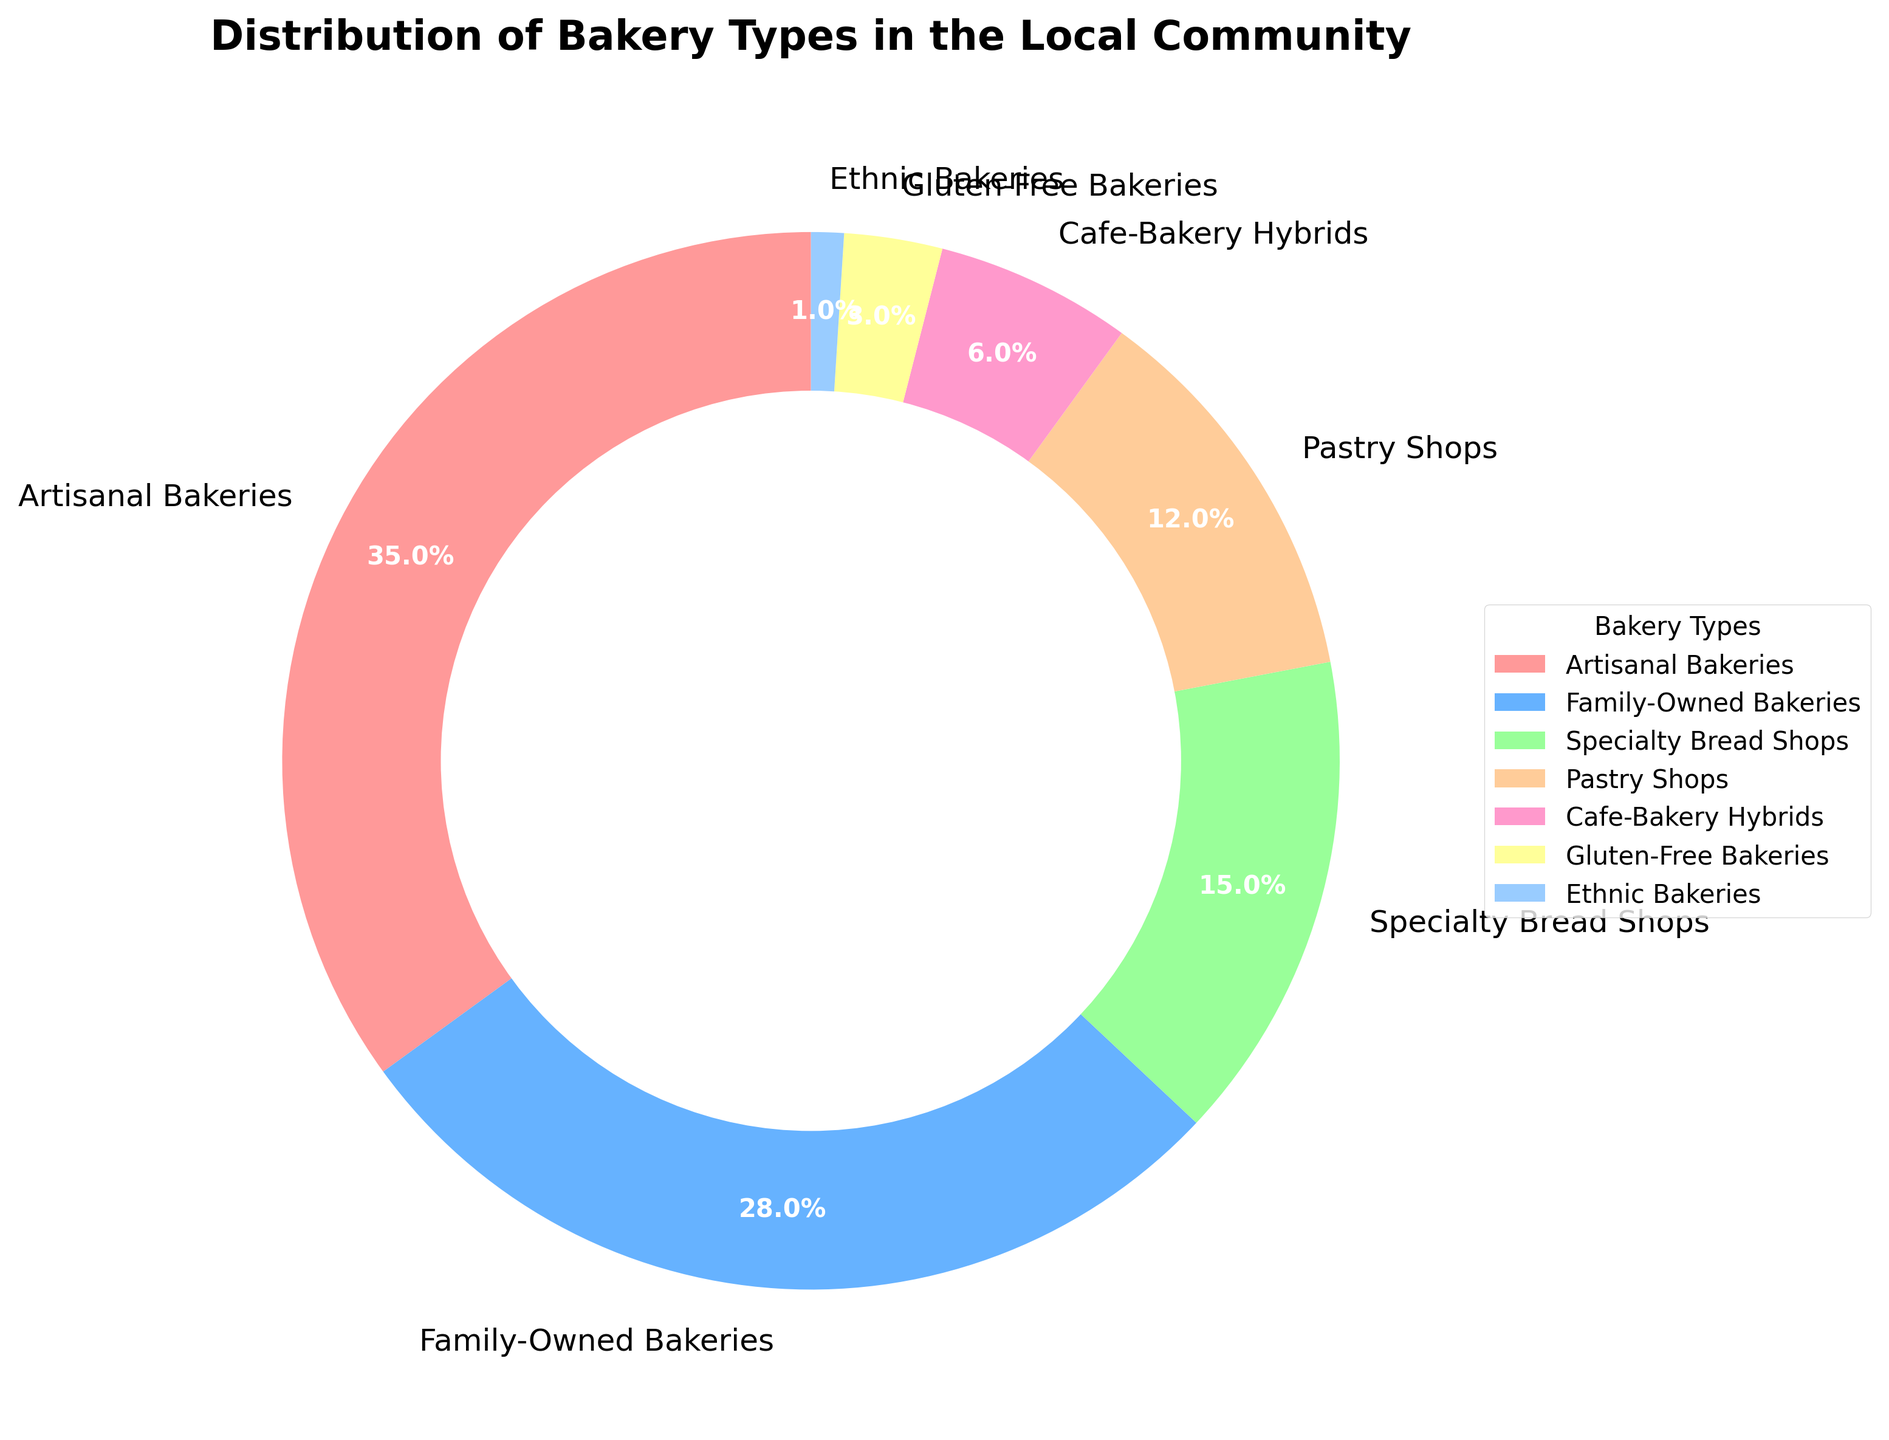How many more percentage points do Artisanal Bakeries have compared to Gluten-Free Bakeries? Artisanal Bakeries have 35%, and Gluten-Free Bakeries have 3%. To find the difference, subtract 3 from 35.
Answer: 32 Which type of bakery has the second-highest percentage? The segment with the second-highest percentage is Family-Owned Bakeries at 28%, just after Artisanal Bakeries at 35%.
Answer: Family-Owned Bakeries What is the combined percentage of Specialty Bread Shops and Pastry Shops? Specialty Bread Shops have 15% and Pastry Shops have 12%. Add these percentages together: 15 + 12.
Answer: 27% Which bakery type is represented by the red color in the pie chart? In the pie chart, the red color corresponds to the largest segment, Artisanal Bakeries, which have a 35% share.
Answer: Artisanal Bakeries What is the ratio of Family-Owned Bakeries to Cafe-Bakery Hybrids? Family-Owned Bakeries have 28%, and Cafe-Bakery Hybrids have 6%. To find the ratio, divide 28 by 6, which simplifies to 14:3.
Answer: 14:3 Of the seven types of bakeries, how many have a share smaller than the average percentage? First, add all the percentages and divide by 7 to find the average: (35 + 28 + 15 + 12 + 6 + 3 + 1) / 7 = 100 / 7 ≈ 14.29. The bakery types with shares below 14.29% are Pastry Shops (12%), Cafe-Bakery Hybrids (6%), Gluten-Free Bakeries (3%), and Ethnic Bakeries (1%), totaling four types.
Answer: 4 types If the Artisanal Bakeries' portion doubled, what would their new percentage be? The current percentage for Artisanal Bakeries is 35%. If it doubles, multiply 35 by 2.
Answer: 70% Which types of bakeries together make up more than half of the total percentage? Adding the percentages from the largest downwards until over 50%: Artisanal Bakeries (35%) + Family-Owned Bakeries (28%) = 63%. These two types together exceed half of the total percentage.
Answer: Artisanal and Family-Owned How many more percentage points do Specialty Bread Shops need to equal the percentage of Family-Owned Bakeries? Family-Owned Bakeries have 28%, and Specialty Bread Shops have 15%. To find the difference, subtract 15 from 28 to find how many more percentage points are needed.
Answer: 13 Do Pastry Shops have more or fewer percentage points than Cafe-Bakery Hybrids plus Gluten-Free Bakeries? Pastry Shops have 12%, while Cafe-Bakery Hybrids have 6% and Gluten-Free Bakeries have 3%. Combining Cafe-Bakery Hybrids and Gluten-Free Bakeries gives 6 + 3 = 9%. Therefore, Pastry Shops have more.
Answer: More 